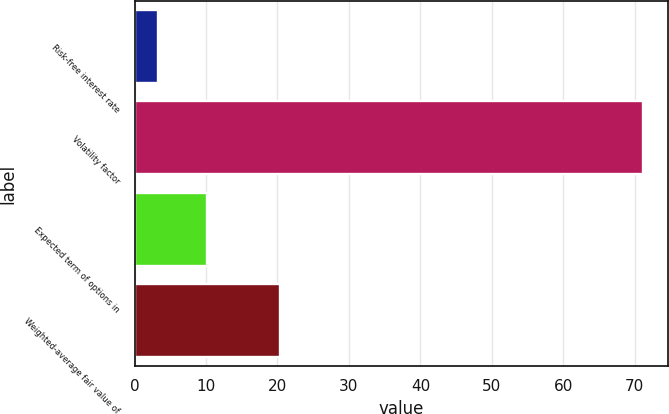Convert chart to OTSL. <chart><loc_0><loc_0><loc_500><loc_500><bar_chart><fcel>Risk-free interest rate<fcel>Volatility factor<fcel>Expected term of options in<fcel>Weighted-average fair value of<nl><fcel>3.32<fcel>71.08<fcel>10.1<fcel>20.38<nl></chart> 